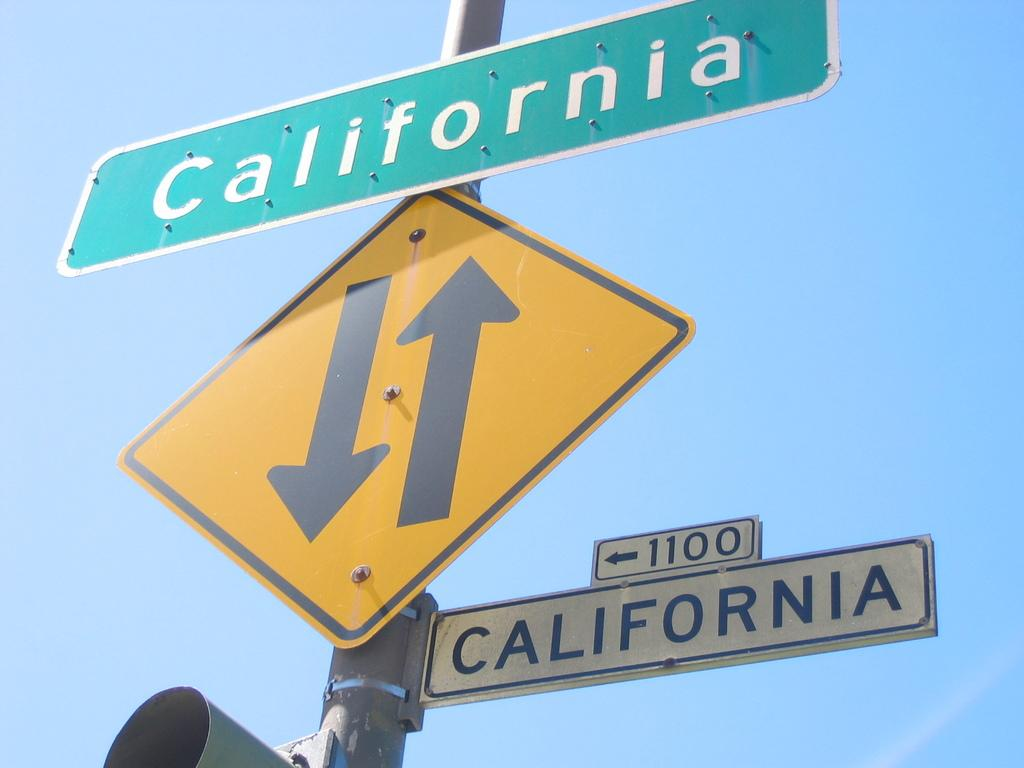<image>
Present a compact description of the photo's key features. California sign on top of a diamond shaped yellow sign. 